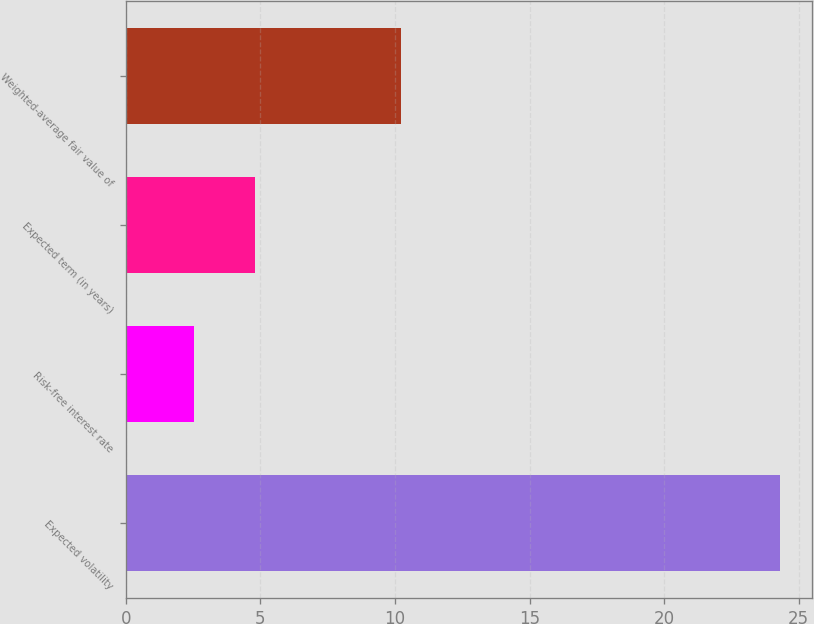<chart> <loc_0><loc_0><loc_500><loc_500><bar_chart><fcel>Expected volatility<fcel>Risk-free interest rate<fcel>Expected term (in years)<fcel>Weighted-average fair value of<nl><fcel>24.3<fcel>2.54<fcel>4.8<fcel>10.24<nl></chart> 